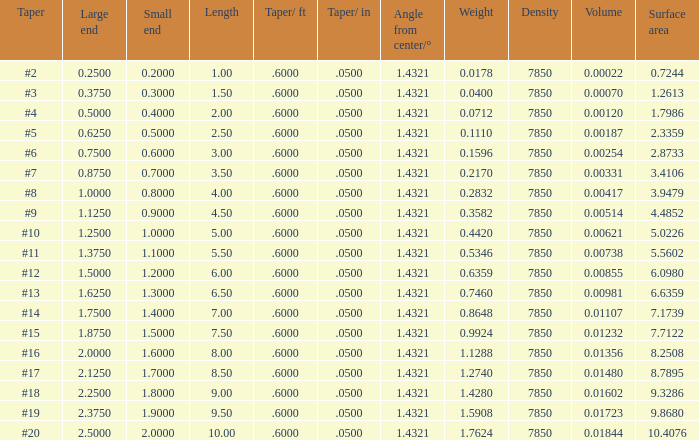Which Angle from center/° has a Taper/ft smaller than 0.6000000000000001? 19.0. 